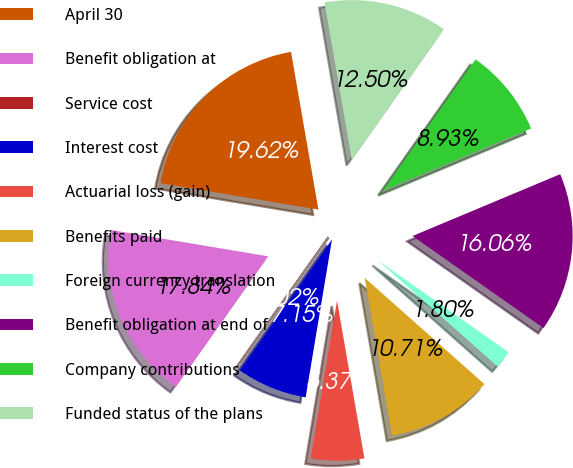Convert chart. <chart><loc_0><loc_0><loc_500><loc_500><pie_chart><fcel>April 30<fcel>Benefit obligation at<fcel>Service cost<fcel>Interest cost<fcel>Actuarial loss (gain)<fcel>Benefits paid<fcel>Foreign currency translation<fcel>Benefit obligation at end of<fcel>Company contributions<fcel>Funded status of the plans<nl><fcel>19.62%<fcel>17.84%<fcel>0.02%<fcel>7.15%<fcel>5.37%<fcel>10.71%<fcel>1.8%<fcel>16.06%<fcel>8.93%<fcel>12.5%<nl></chart> 